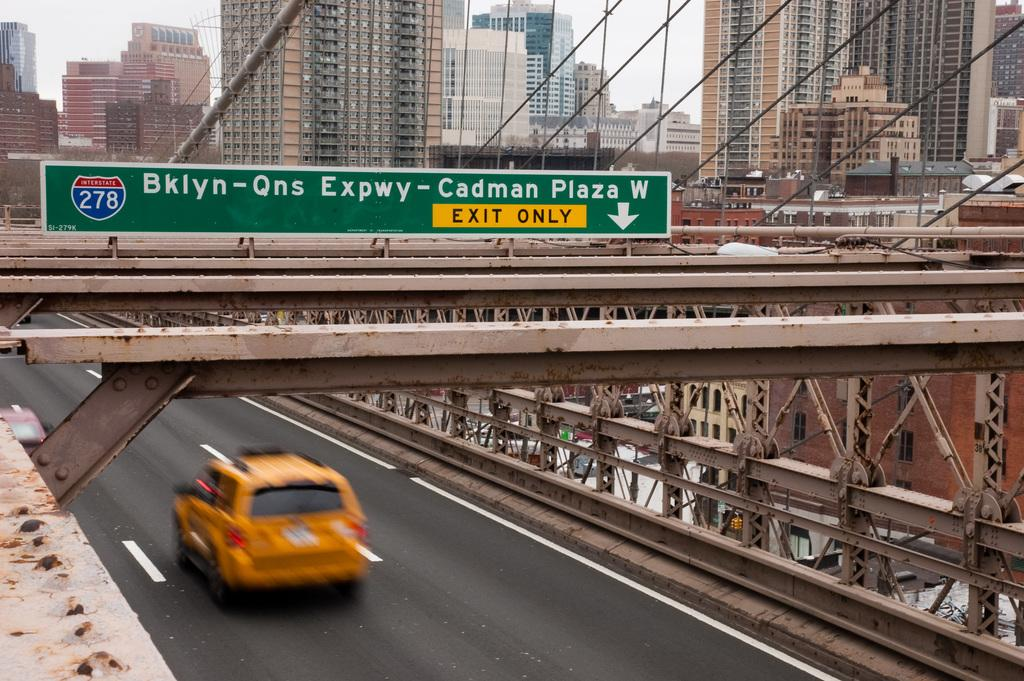<image>
Create a compact narrative representing the image presented. A sign points to the exit for highway 278 in the city. 